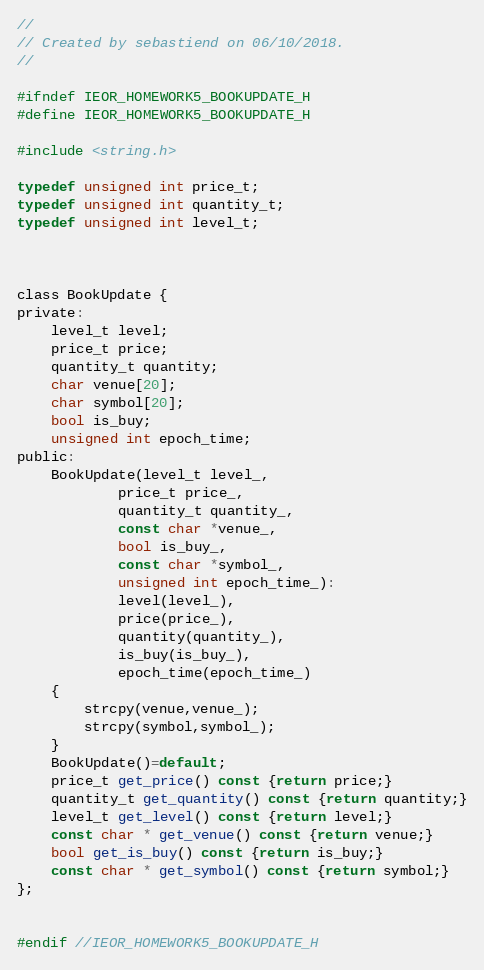<code> <loc_0><loc_0><loc_500><loc_500><_C_>//
// Created by sebastiend on 06/10/2018.
//

#ifndef IEOR_HOMEWORK5_BOOKUPDATE_H
#define IEOR_HOMEWORK5_BOOKUPDATE_H

#include <string.h>

typedef unsigned int price_t;
typedef unsigned int quantity_t;
typedef unsigned int level_t;



class BookUpdate {
private:
    level_t level;
    price_t price;
    quantity_t quantity;
    char venue[20];
    char symbol[20];
    bool is_buy;
    unsigned int epoch_time;
public:
    BookUpdate(level_t level_,
            price_t price_,
            quantity_t quantity_,
            const char *venue_,
            bool is_buy_,
            const char *symbol_,
            unsigned int epoch_time_):
            level(level_),
            price(price_),
            quantity(quantity_),
            is_buy(is_buy_),
            epoch_time(epoch_time_)
    {
        strcpy(venue,venue_);
        strcpy(symbol,symbol_);
    }
    BookUpdate()=default;
    price_t get_price() const {return price;}
    quantity_t get_quantity() const {return quantity;}
    level_t get_level() const {return level;}
    const char * get_venue() const {return venue;}
    bool get_is_buy() const {return is_buy;}
    const char * get_symbol() const {return symbol;}
};


#endif //IEOR_HOMEWORK5_BOOKUPDATE_H
</code> 